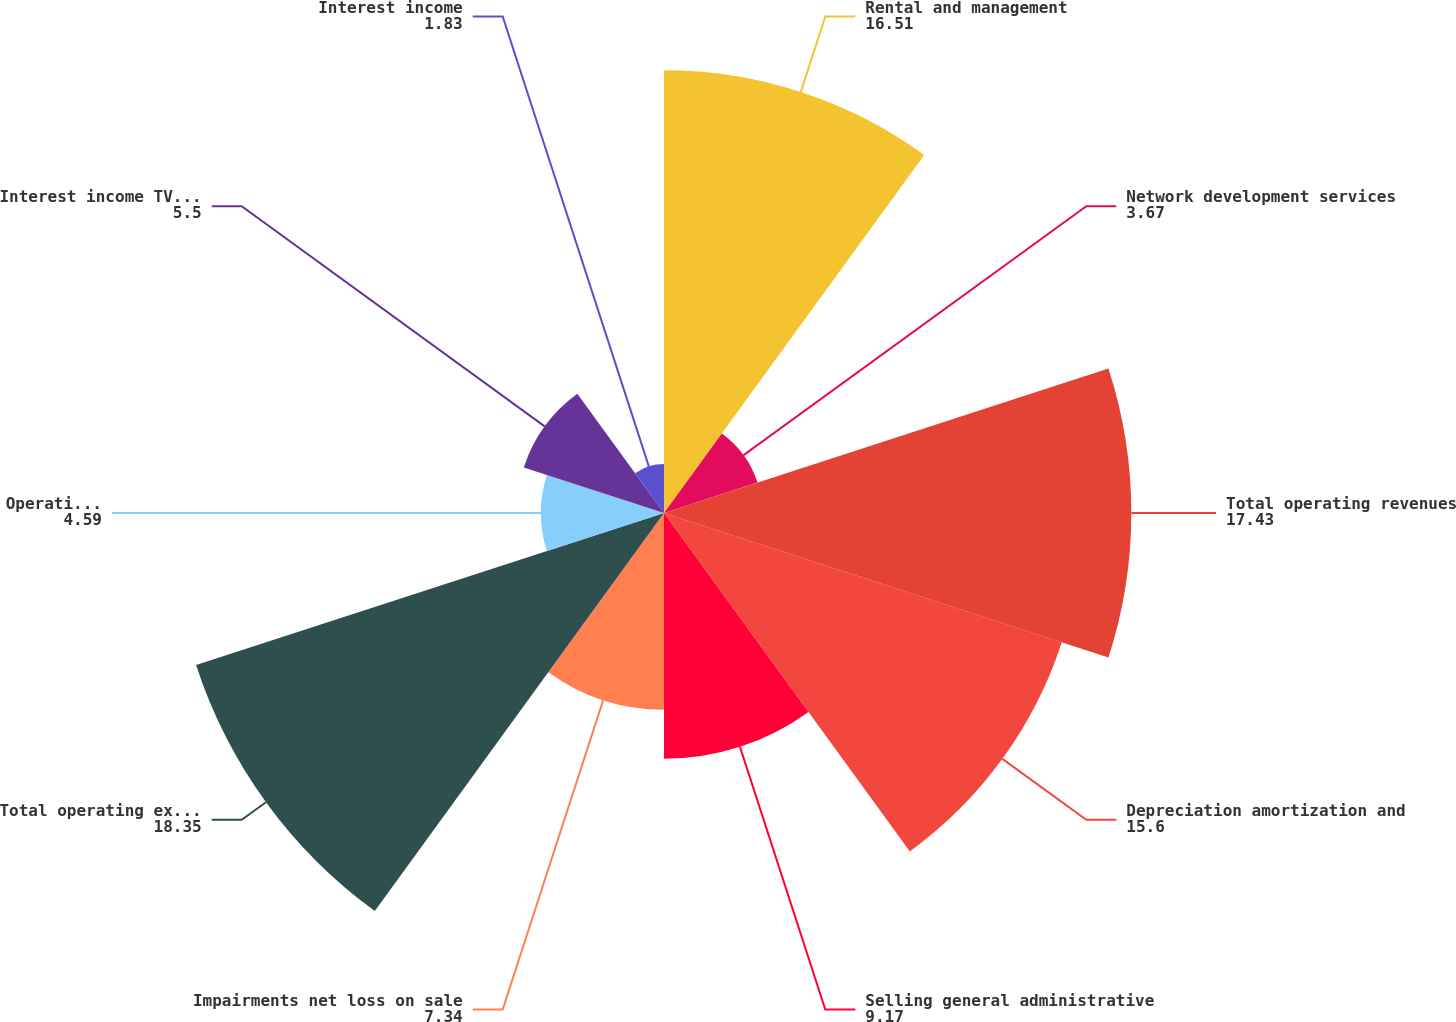Convert chart. <chart><loc_0><loc_0><loc_500><loc_500><pie_chart><fcel>Rental and management<fcel>Network development services<fcel>Total operating revenues<fcel>Depreciation amortization and<fcel>Selling general administrative<fcel>Impairments net loss on sale<fcel>Total operating expenses<fcel>Operating income (loss)<fcel>Interest income TV Azteca net<fcel>Interest income<nl><fcel>16.51%<fcel>3.67%<fcel>17.43%<fcel>15.6%<fcel>9.17%<fcel>7.34%<fcel>18.35%<fcel>4.59%<fcel>5.5%<fcel>1.83%<nl></chart> 